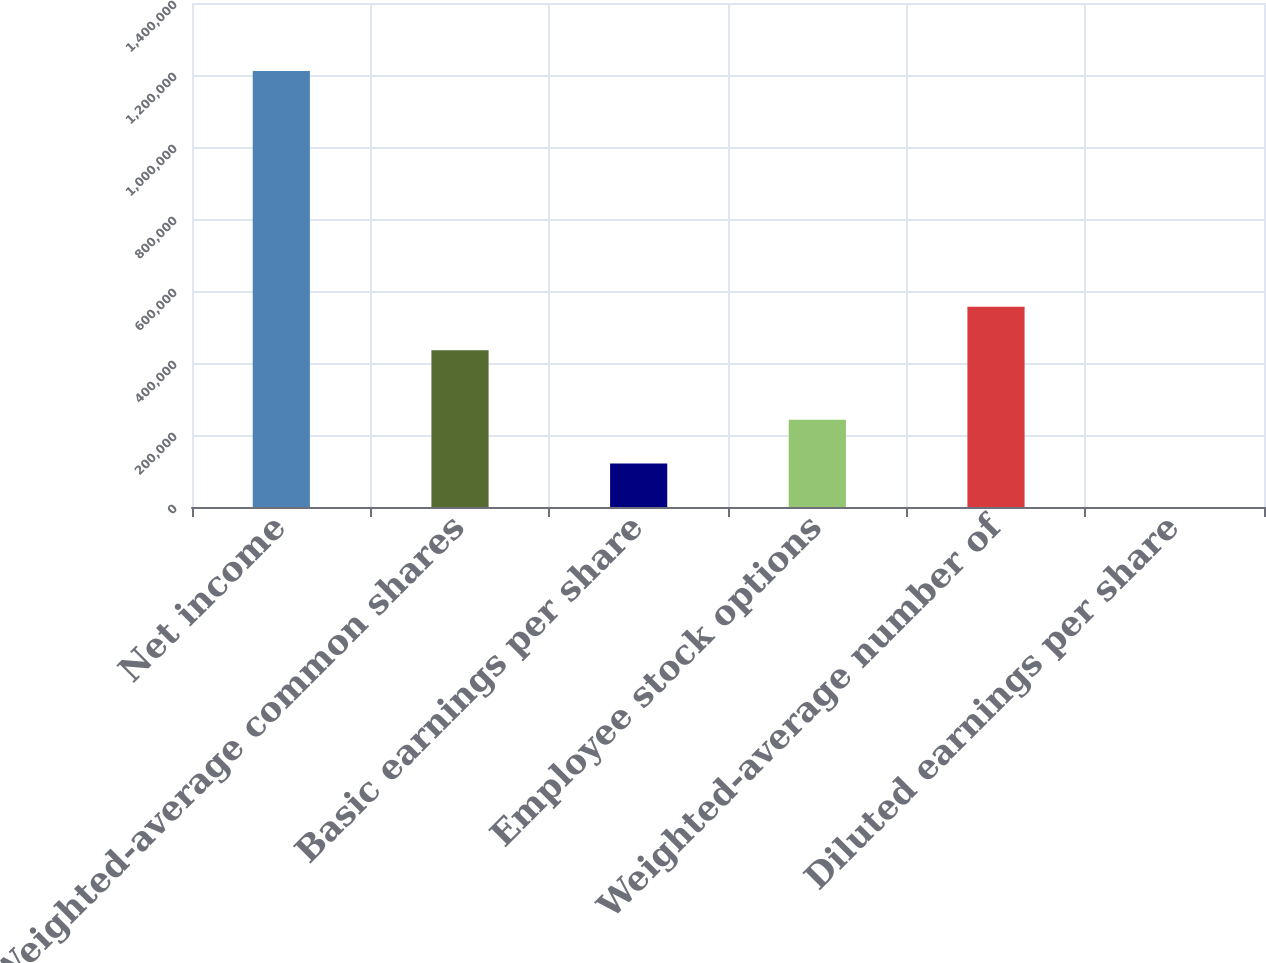Convert chart to OTSL. <chart><loc_0><loc_0><loc_500><loc_500><bar_chart><fcel>Net income<fcel>Weighted-average common shares<fcel>Basic earnings per share<fcel>Employee stock options<fcel>Weighted-average number of<fcel>Diluted earnings per share<nl><fcel>1.21124e+06<fcel>435374<fcel>121127<fcel>242251<fcel>556498<fcel>2.68<nl></chart> 